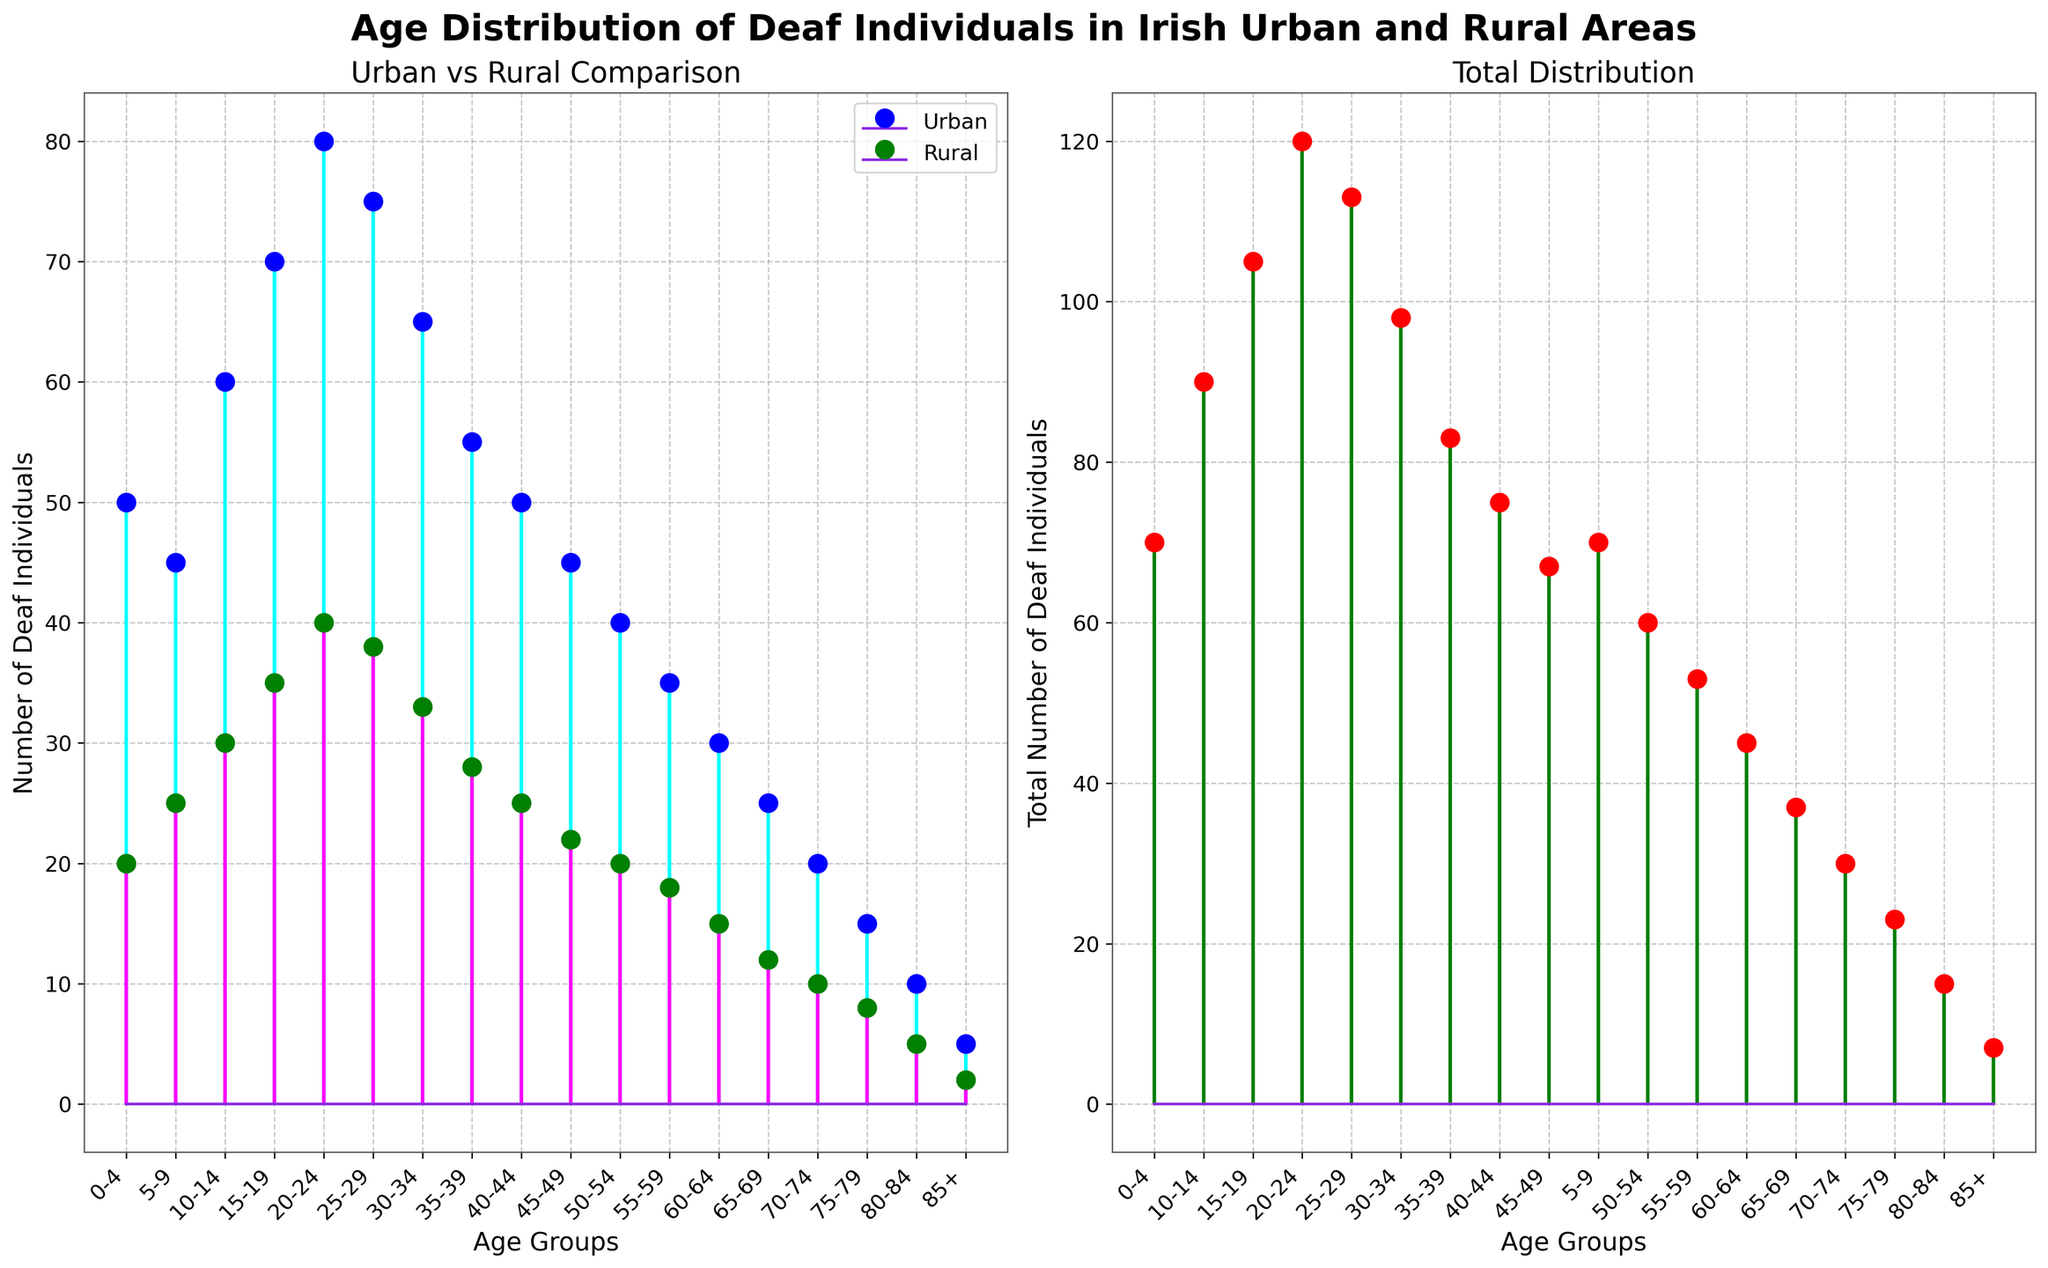What is the title of the figure? The title is located at the top of the figure and is in bold, large font. It reads "Age Distribution of Deaf Individuals in Irish Urban and Rural Areas".
Answer: Age Distribution of Deaf Individuals in Irish Urban and Rural Areas Which age group has the highest number of Deaf individuals in urban areas? Looking at the urban stem plot (left subplot), the highest point corresponds to the 20-24 age group.
Answer: 20-24 What is the total number of Deaf individuals in the 15-19 age group? Referring to the right subplot for the total distribution and summing the counts for urban and rural in the 15-19 age group: Urban (70) + Rural(35) = 105.
Answer: 105 Which age group shows the largest difference in the number of individuals between urban and rural areas? The largest difference can be identified by comparing the heights of the stems in the left subplot. The largest difference is observed for the 20-24 age group: 80 (Urban) - 40 (Rural) = 40.
Answer: 20-24 Among the age groups of 55-59 and 60-64, which one has a higher count of Deaf individuals in rural areas? Comparing the heights of the green markers for these two age groups on the left subplot, 55-59 has a rural count of 18 and 60-64 has a rural count of 15.
Answer: 55-59 What is the total number of Deaf individuals across all age groups? Summing up the values from the total distribution plot (right subplot): 70 + 70 + 90 + 105 + 120 + 113 + 98 + 83 + 75 + 67 + 55 + 48 + 37 + 30 + 20 + 15 + 7 = 1093.
Answer: 1093 How does the number of Deaf individuals in the youngest age group (0-4) compare between urban and rural areas? Referring to the left subplot, the urban count is 50 and the rural count is 20. Thus, the urban count is higher.
Answer: Urban has more In which subplot can you find the total count of Deaf individuals per age group? The total distribution per age group is shown in the right subplot with the title "Total Distribution".
Answer: Right subplot Which age group has the smallest total number of Deaf individuals, and what is that number? The smallest total is observed in the right subplot. The age group is 85+ with a total count of 7 (5 Urban + 2 Rural).
Answer: 85+, 7 What are the marker colors for urban and rural areas in the left subplot? The markers in the left subplot use different colors to distinguish urban and rural areas. Urban is represented by blue markers, while rural is represented by green markers.
Answer: Blue (Urban), Green (Rural) 